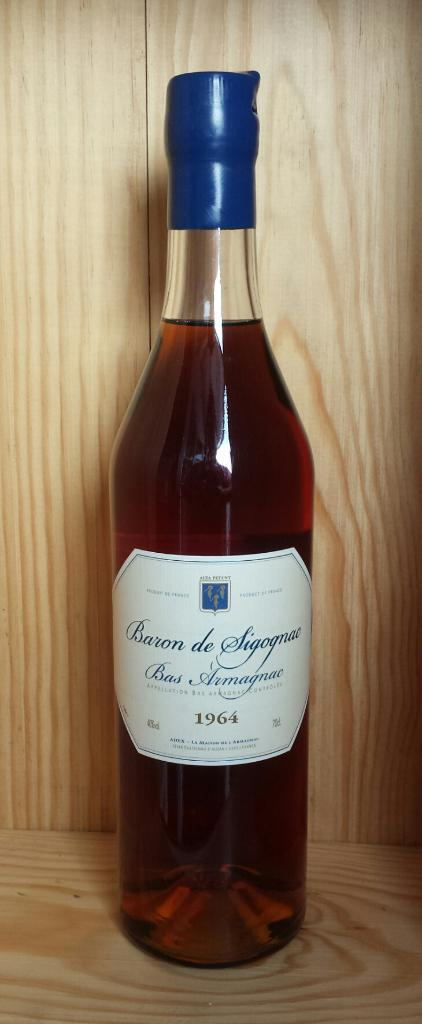What is the main object in the image? There is a wine bottle in the image. Where is the wine bottle located? The wine bottle is kept on a wooden shelf. What type of organization does the lawyer represent in the image? There is no lawyer or organization present in the image; it only features a wine bottle on a wooden shelf. 